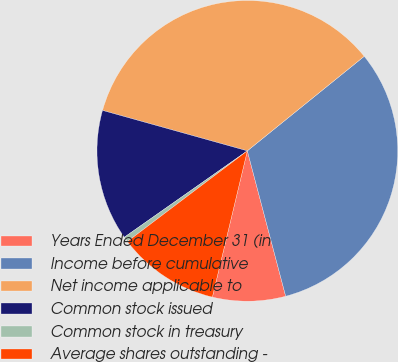Convert chart. <chart><loc_0><loc_0><loc_500><loc_500><pie_chart><fcel>Years Ended December 31 (in<fcel>Income before cumulative<fcel>Net income applicable to<fcel>Common stock issued<fcel>Common stock in treasury<fcel>Average shares outstanding -<nl><fcel>7.84%<fcel>31.72%<fcel>34.84%<fcel>14.08%<fcel>0.56%<fcel>10.96%<nl></chart> 